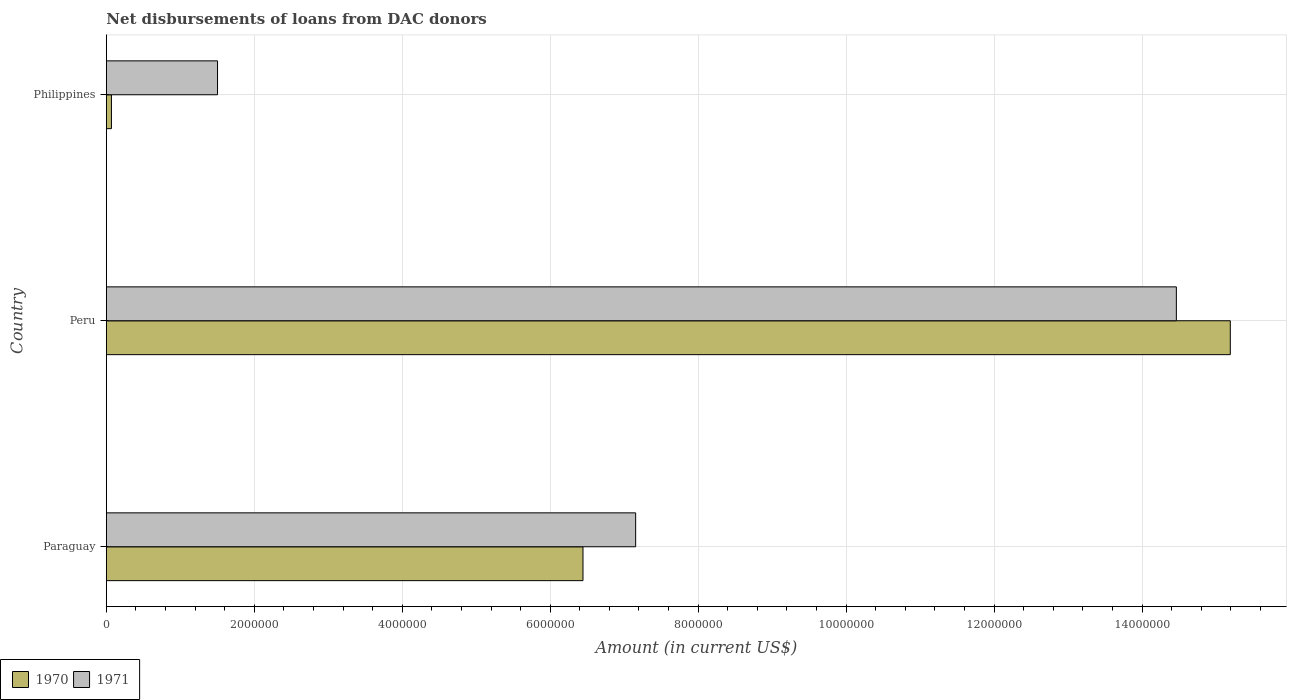How many groups of bars are there?
Your answer should be very brief. 3. How many bars are there on the 3rd tick from the bottom?
Your response must be concise. 2. What is the amount of loans disbursed in 1971 in Paraguay?
Your answer should be very brief. 7.16e+06. Across all countries, what is the maximum amount of loans disbursed in 1971?
Offer a terse response. 1.45e+07. Across all countries, what is the minimum amount of loans disbursed in 1970?
Ensure brevity in your answer.  6.90e+04. What is the total amount of loans disbursed in 1970 in the graph?
Provide a short and direct response. 2.17e+07. What is the difference between the amount of loans disbursed in 1971 in Paraguay and that in Philippines?
Ensure brevity in your answer.  5.65e+06. What is the difference between the amount of loans disbursed in 1970 in Paraguay and the amount of loans disbursed in 1971 in Peru?
Give a very brief answer. -8.02e+06. What is the average amount of loans disbursed in 1971 per country?
Ensure brevity in your answer.  7.71e+06. What is the difference between the amount of loans disbursed in 1970 and amount of loans disbursed in 1971 in Paraguay?
Your response must be concise. -7.12e+05. In how many countries, is the amount of loans disbursed in 1971 greater than 3600000 US$?
Your answer should be very brief. 2. What is the ratio of the amount of loans disbursed in 1970 in Paraguay to that in Philippines?
Offer a terse response. 93.38. Is the amount of loans disbursed in 1971 in Paraguay less than that in Philippines?
Provide a succinct answer. No. Is the difference between the amount of loans disbursed in 1970 in Paraguay and Peru greater than the difference between the amount of loans disbursed in 1971 in Paraguay and Peru?
Provide a succinct answer. No. What is the difference between the highest and the second highest amount of loans disbursed in 1970?
Provide a short and direct response. 8.75e+06. What is the difference between the highest and the lowest amount of loans disbursed in 1970?
Your answer should be very brief. 1.51e+07. In how many countries, is the amount of loans disbursed in 1970 greater than the average amount of loans disbursed in 1970 taken over all countries?
Provide a succinct answer. 1. What does the 2nd bar from the top in Peru represents?
Keep it short and to the point. 1970. What does the 1st bar from the bottom in Philippines represents?
Give a very brief answer. 1970. How many legend labels are there?
Your answer should be compact. 2. How are the legend labels stacked?
Provide a succinct answer. Horizontal. What is the title of the graph?
Ensure brevity in your answer.  Net disbursements of loans from DAC donors. Does "1969" appear as one of the legend labels in the graph?
Your response must be concise. No. What is the label or title of the X-axis?
Keep it short and to the point. Amount (in current US$). What is the Amount (in current US$) of 1970 in Paraguay?
Make the answer very short. 6.44e+06. What is the Amount (in current US$) in 1971 in Paraguay?
Your answer should be very brief. 7.16e+06. What is the Amount (in current US$) of 1970 in Peru?
Offer a terse response. 1.52e+07. What is the Amount (in current US$) in 1971 in Peru?
Provide a succinct answer. 1.45e+07. What is the Amount (in current US$) of 1970 in Philippines?
Give a very brief answer. 6.90e+04. What is the Amount (in current US$) in 1971 in Philippines?
Ensure brevity in your answer.  1.50e+06. Across all countries, what is the maximum Amount (in current US$) of 1970?
Ensure brevity in your answer.  1.52e+07. Across all countries, what is the maximum Amount (in current US$) of 1971?
Provide a succinct answer. 1.45e+07. Across all countries, what is the minimum Amount (in current US$) in 1970?
Your response must be concise. 6.90e+04. Across all countries, what is the minimum Amount (in current US$) of 1971?
Make the answer very short. 1.50e+06. What is the total Amount (in current US$) in 1970 in the graph?
Give a very brief answer. 2.17e+07. What is the total Amount (in current US$) in 1971 in the graph?
Your answer should be very brief. 2.31e+07. What is the difference between the Amount (in current US$) of 1970 in Paraguay and that in Peru?
Make the answer very short. -8.75e+06. What is the difference between the Amount (in current US$) in 1971 in Paraguay and that in Peru?
Ensure brevity in your answer.  -7.31e+06. What is the difference between the Amount (in current US$) of 1970 in Paraguay and that in Philippines?
Provide a short and direct response. 6.37e+06. What is the difference between the Amount (in current US$) of 1971 in Paraguay and that in Philippines?
Your answer should be compact. 5.65e+06. What is the difference between the Amount (in current US$) of 1970 in Peru and that in Philippines?
Your answer should be compact. 1.51e+07. What is the difference between the Amount (in current US$) of 1971 in Peru and that in Philippines?
Keep it short and to the point. 1.30e+07. What is the difference between the Amount (in current US$) in 1970 in Paraguay and the Amount (in current US$) in 1971 in Peru?
Provide a succinct answer. -8.02e+06. What is the difference between the Amount (in current US$) of 1970 in Paraguay and the Amount (in current US$) of 1971 in Philippines?
Make the answer very short. 4.94e+06. What is the difference between the Amount (in current US$) of 1970 in Peru and the Amount (in current US$) of 1971 in Philippines?
Your answer should be compact. 1.37e+07. What is the average Amount (in current US$) of 1970 per country?
Your answer should be compact. 7.24e+06. What is the average Amount (in current US$) of 1971 per country?
Your answer should be very brief. 7.71e+06. What is the difference between the Amount (in current US$) of 1970 and Amount (in current US$) of 1971 in Paraguay?
Offer a terse response. -7.12e+05. What is the difference between the Amount (in current US$) of 1970 and Amount (in current US$) of 1971 in Peru?
Give a very brief answer. 7.29e+05. What is the difference between the Amount (in current US$) in 1970 and Amount (in current US$) in 1971 in Philippines?
Provide a succinct answer. -1.43e+06. What is the ratio of the Amount (in current US$) in 1970 in Paraguay to that in Peru?
Offer a very short reply. 0.42. What is the ratio of the Amount (in current US$) in 1971 in Paraguay to that in Peru?
Your answer should be compact. 0.49. What is the ratio of the Amount (in current US$) in 1970 in Paraguay to that in Philippines?
Offer a very short reply. 93.38. What is the ratio of the Amount (in current US$) in 1971 in Paraguay to that in Philippines?
Your answer should be very brief. 4.76. What is the ratio of the Amount (in current US$) of 1970 in Peru to that in Philippines?
Your response must be concise. 220.19. What is the ratio of the Amount (in current US$) in 1971 in Peru to that in Philippines?
Ensure brevity in your answer.  9.62. What is the difference between the highest and the second highest Amount (in current US$) in 1970?
Offer a terse response. 8.75e+06. What is the difference between the highest and the second highest Amount (in current US$) in 1971?
Your answer should be compact. 7.31e+06. What is the difference between the highest and the lowest Amount (in current US$) in 1970?
Offer a terse response. 1.51e+07. What is the difference between the highest and the lowest Amount (in current US$) of 1971?
Ensure brevity in your answer.  1.30e+07. 